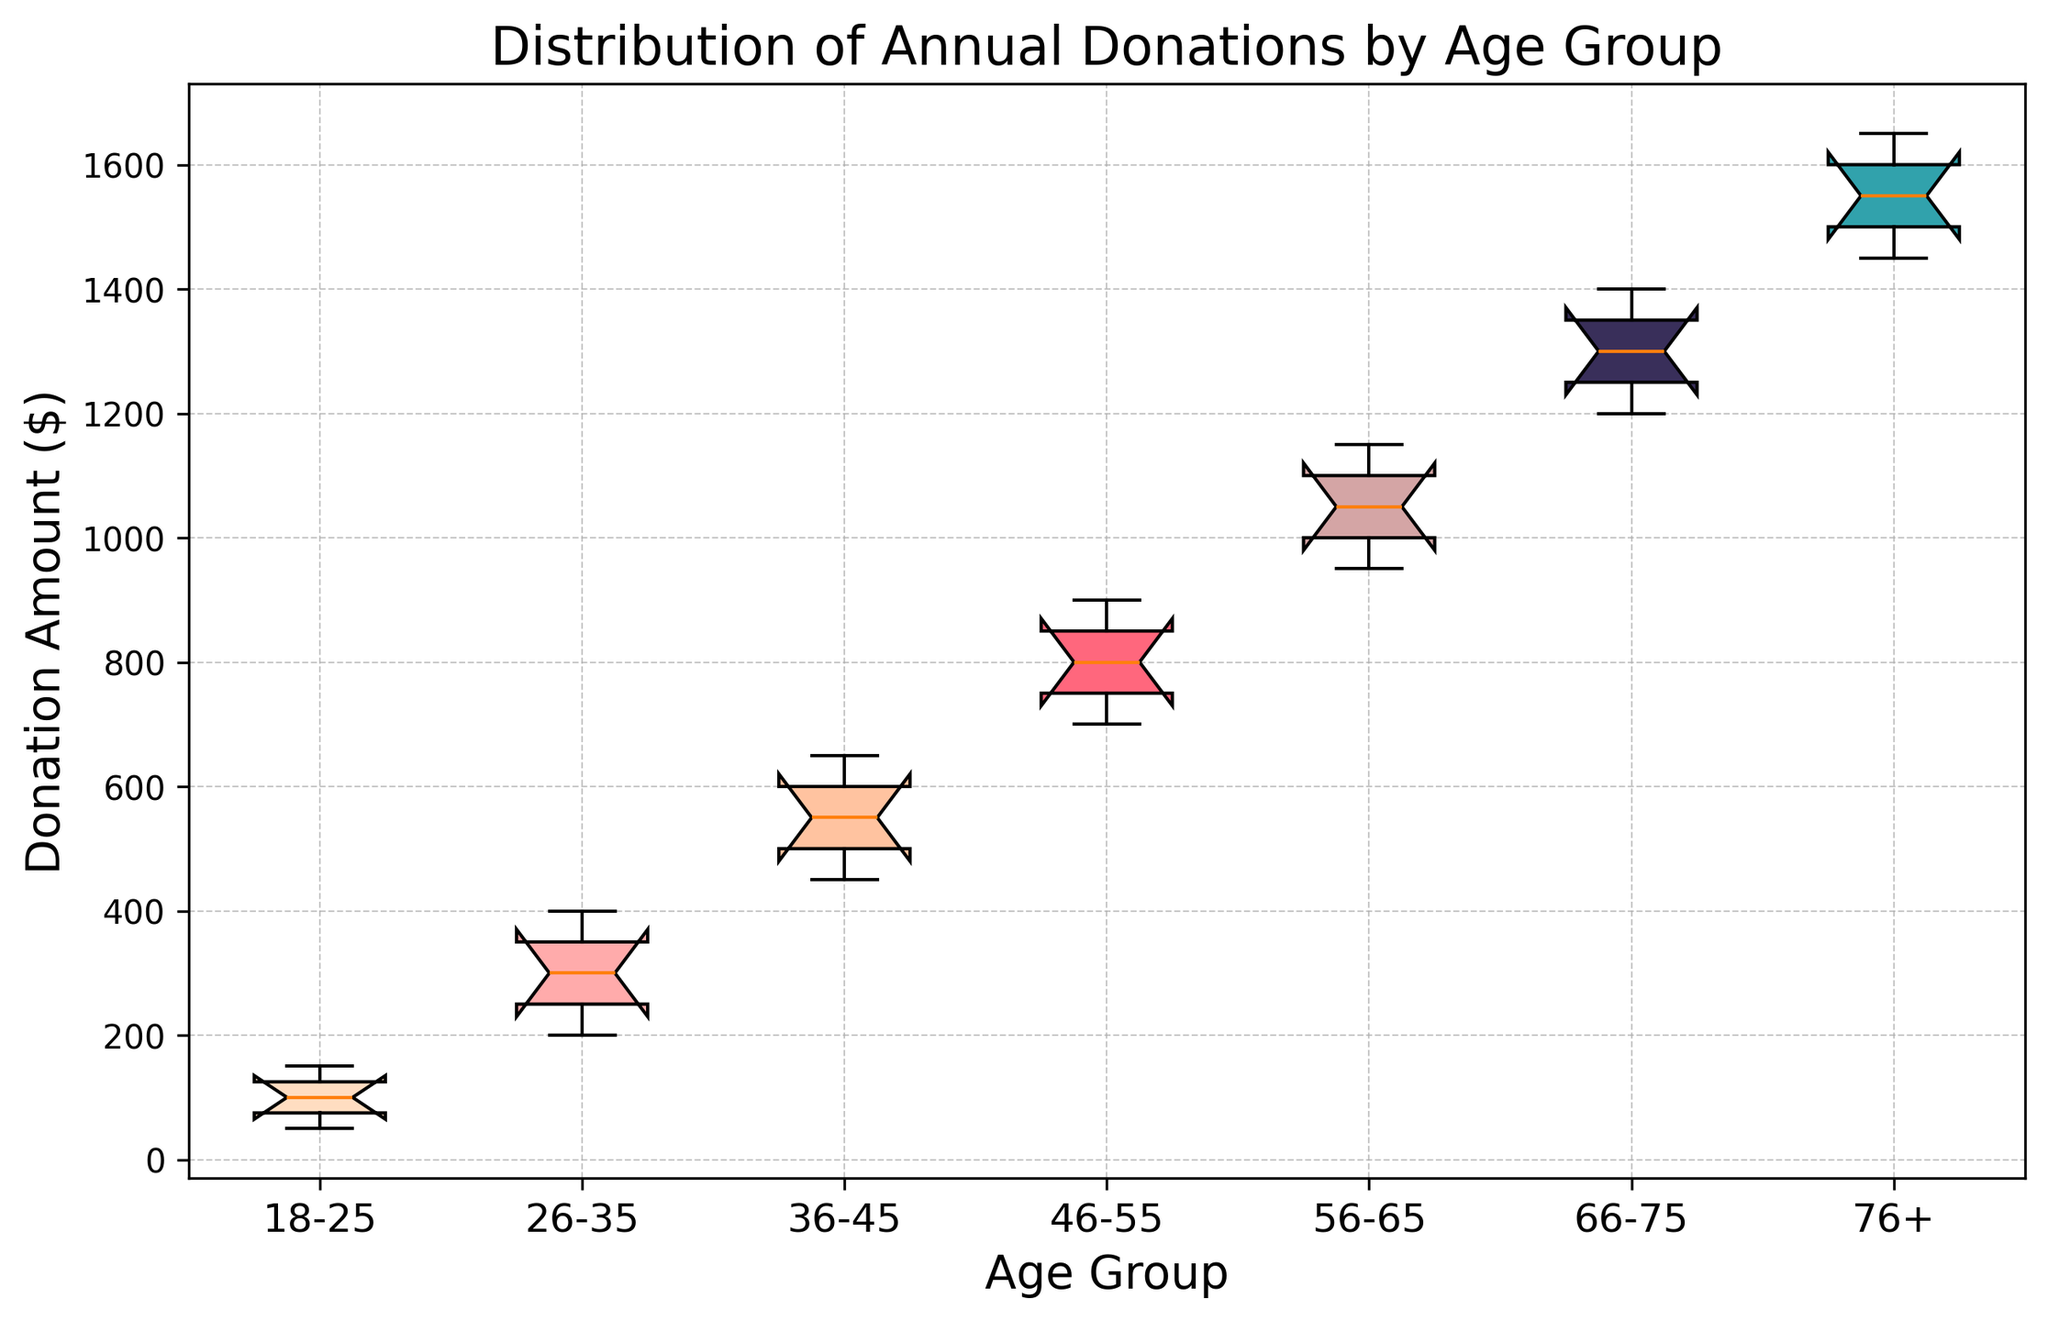What age group has the highest median donation amount? The box plot's middle line within each box represents the median donation amount. The age group with the highest middle line is 76+.
Answer: 76+ Which age group has the most consistent donation amounts, and how can you tell? Consistency is measured by the range of the donations, which is the height of the box (interquartile range). The 18-25 age group has the shortest box, indicating the most consistent donation amounts.
Answer: 18-25 What is the range of donations for the age group 46-55? The range is calculated by the difference between the maximum and minimum whisker of the box plot. For the 46-55 age group, this ranges from approximately 700 to 900.
Answer: 200 Compare the interquartile ranges (IQR) of the age groups 36-45 and 66-75. Which is larger, and by how much? The IQR is the height of the box, spanning from the lower quartile to the upper quartile. Visually, the 66-75 age group has a taller box compared to 36-45. It shows a more extensive span.
Answer: 66-75, by approximately $50 What visual attribute can help determine the spread of donations within each age group? The height of the box in the box plot indicates the spread of the middle 50% of donations (IQR). The whiskers show the overall spread including potential outliers.
Answer: Height of the box and whiskers Which age group demonstrates the highest variability in donation amounts? Variability is indicated by the height of the box and the length of the whiskers. The age group 66-75 exhibits the tallest box and longest whiskers, suggesting the highest variability.
Answer: 66-75 For which age group does the median donation amount fall approximately in the middle of the IQR? When the median (middle line) is centrally placed in the box, it suggests a symmetrical distribution. For age group 56-65, the median line appears centrally located within the box.
Answer: 56-65 How do the median donation amounts of the age groups 26-35 and 46-55 compare? The median line in the 46-55 age group is above that of the 26-35 age group, indicating higher median donations in 46-55.
Answer: 46-55 has a higher median What can be said about the distribution of donations for age group 18-25 based on the box plot? The narrow height of the box and short whiskers show that donations in the 18-25 age group are very consistent and do not vary widely.
Answer: Consistent, low variability 